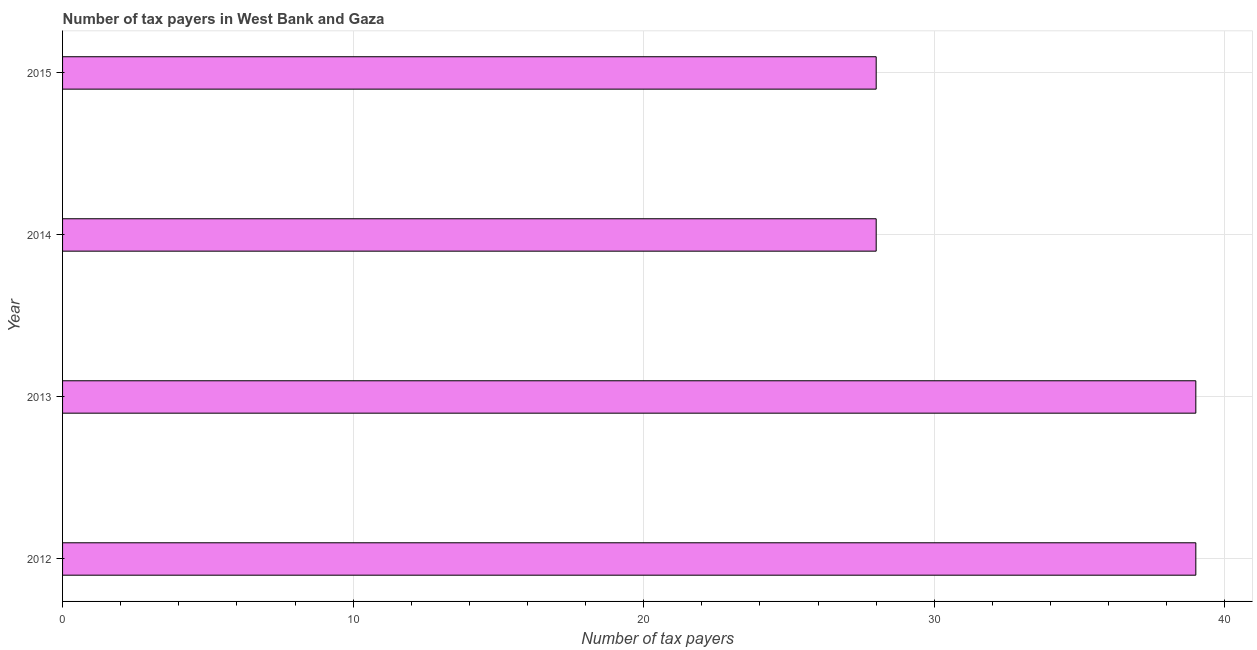What is the title of the graph?
Make the answer very short. Number of tax payers in West Bank and Gaza. What is the label or title of the X-axis?
Ensure brevity in your answer.  Number of tax payers. What is the label or title of the Y-axis?
Ensure brevity in your answer.  Year. Across all years, what is the minimum number of tax payers?
Provide a short and direct response. 28. In which year was the number of tax payers maximum?
Ensure brevity in your answer.  2012. In which year was the number of tax payers minimum?
Ensure brevity in your answer.  2014. What is the sum of the number of tax payers?
Keep it short and to the point. 134. What is the average number of tax payers per year?
Offer a very short reply. 33. What is the median number of tax payers?
Keep it short and to the point. 33.5. What is the ratio of the number of tax payers in 2012 to that in 2014?
Your response must be concise. 1.39. Is the difference between the number of tax payers in 2014 and 2015 greater than the difference between any two years?
Ensure brevity in your answer.  No. In how many years, is the number of tax payers greater than the average number of tax payers taken over all years?
Give a very brief answer. 2. How many bars are there?
Offer a very short reply. 4. Are all the bars in the graph horizontal?
Your answer should be compact. Yes. Are the values on the major ticks of X-axis written in scientific E-notation?
Your answer should be very brief. No. What is the Number of tax payers of 2013?
Ensure brevity in your answer.  39. What is the difference between the Number of tax payers in 2012 and 2014?
Your response must be concise. 11. What is the difference between the Number of tax payers in 2013 and 2014?
Provide a short and direct response. 11. What is the difference between the Number of tax payers in 2014 and 2015?
Give a very brief answer. 0. What is the ratio of the Number of tax payers in 2012 to that in 2014?
Your answer should be very brief. 1.39. What is the ratio of the Number of tax payers in 2012 to that in 2015?
Provide a short and direct response. 1.39. What is the ratio of the Number of tax payers in 2013 to that in 2014?
Your answer should be very brief. 1.39. What is the ratio of the Number of tax payers in 2013 to that in 2015?
Offer a terse response. 1.39. What is the ratio of the Number of tax payers in 2014 to that in 2015?
Your answer should be compact. 1. 